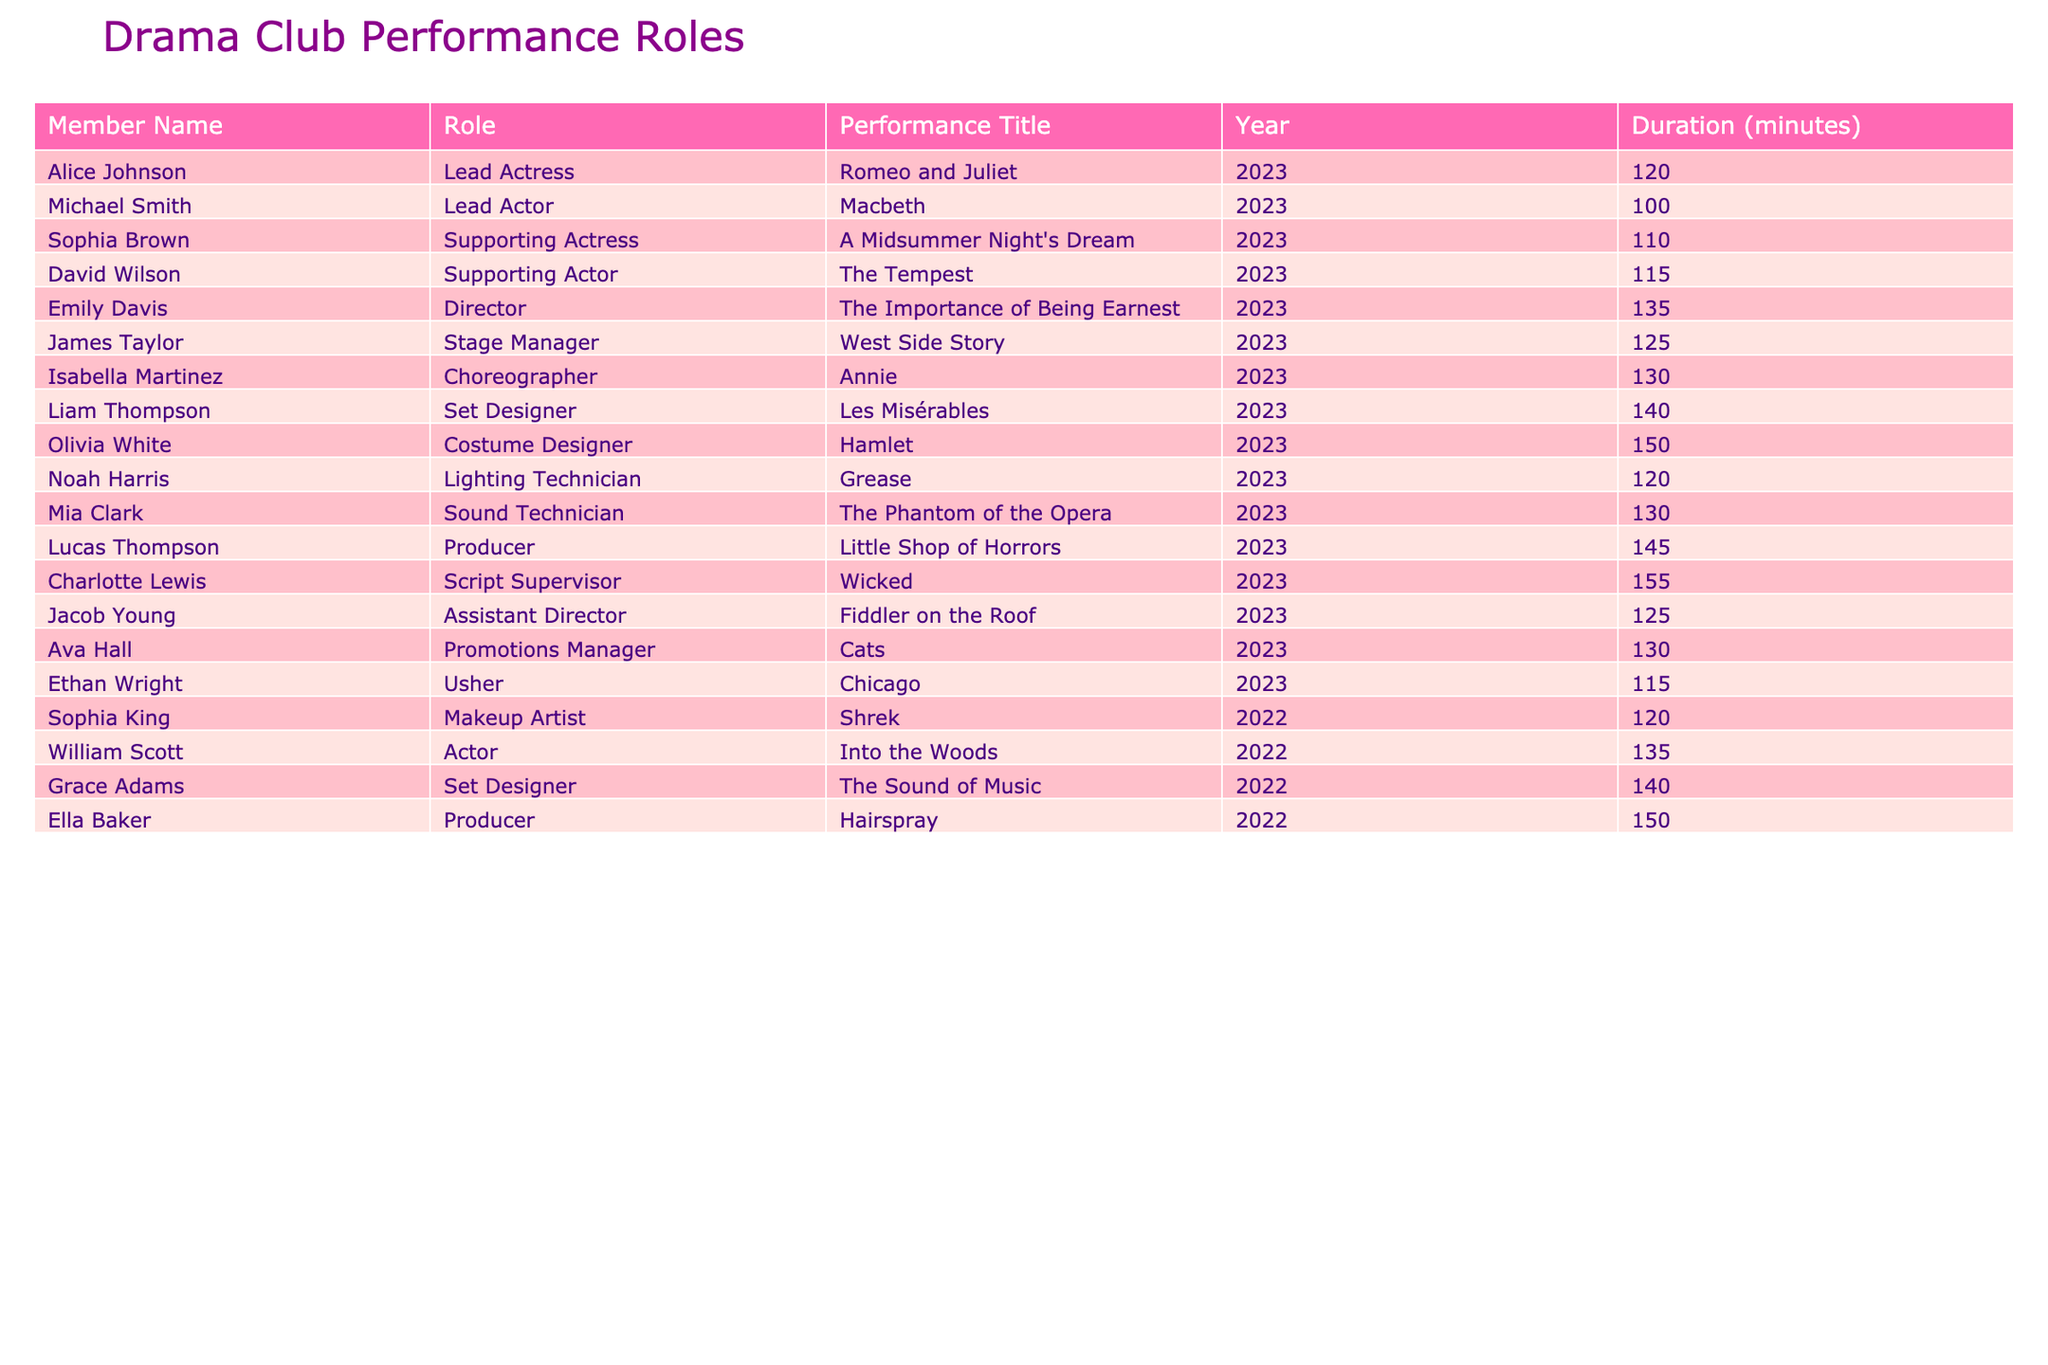What is the title of the performance in which Emily Davis was the director? By looking at the table, Emily Davis is listed as the Director for "The Importance of Being Earnest".
Answer: The Importance of Being Earnest Who played the role of Lead Actor in 2023? The table shows that Michael Smith played the role of Lead Actor in the performance of "Macbeth" in 2023.
Answer: Michael Smith How many minutes was the performance "Annie" directed by Isabella Martinez? The table indicates that the duration of the performance "Annie", for which Isabella Martinez was the Choreographer, is 130 minutes.
Answer: 130 minutes What is the total duration of all performances in 2023? To find the total duration, we add up the individual durations: 120 + 100 + 110 + 115 + 135 + 125 + 130 + 140 + 150 + 120 + 130 + 145 + 155 + 125 + 130 + 115. This equals 1,810 minutes.
Answer: 1810 minutes Which role has the longest duration in 2023? By examining the durations in 2023, Olivia White as the Costume Designer in "Hamlet" has the longest duration of 150 minutes.
Answer: Costume Designer Did any member participate as an Usher in 2022? The table shows that Ethan Wright was an Usher in 2023, but there are no records in 2022 listing anyone as an Usher.
Answer: No What is the average duration of performances in 2022? In 2022, the performances and their durations are 135 (Into the Woods), 140 (The Sound of Music), and 150 (Hairspray). The average duration is calculated as (135 + 140 + 150) / 3 = 141.67 minutes.
Answer: 141.67 minutes How many members played roles in both 2022 and 2023? Reviewing the table, members Sophia King and Ella Baker performed in 2022, but no other members are listed for both years. Thus, the count is zero for overlapping roles.
Answer: 0 members What percentage of the performances in 2023 were directed by women? There are three directors for 2023 and only one, Emily Davis, is female, which makes it approximately 33.33% women directors (1 out of 3).
Answer: 33.33% Which performance involved the most members in the roles listed? By counting the number of members for each performance, "Wicked" has the highest number of members involved (Charlotte Lewis, Jacob Young). Thus, it stands out for the number of roles listed.
Answer: Wicked 